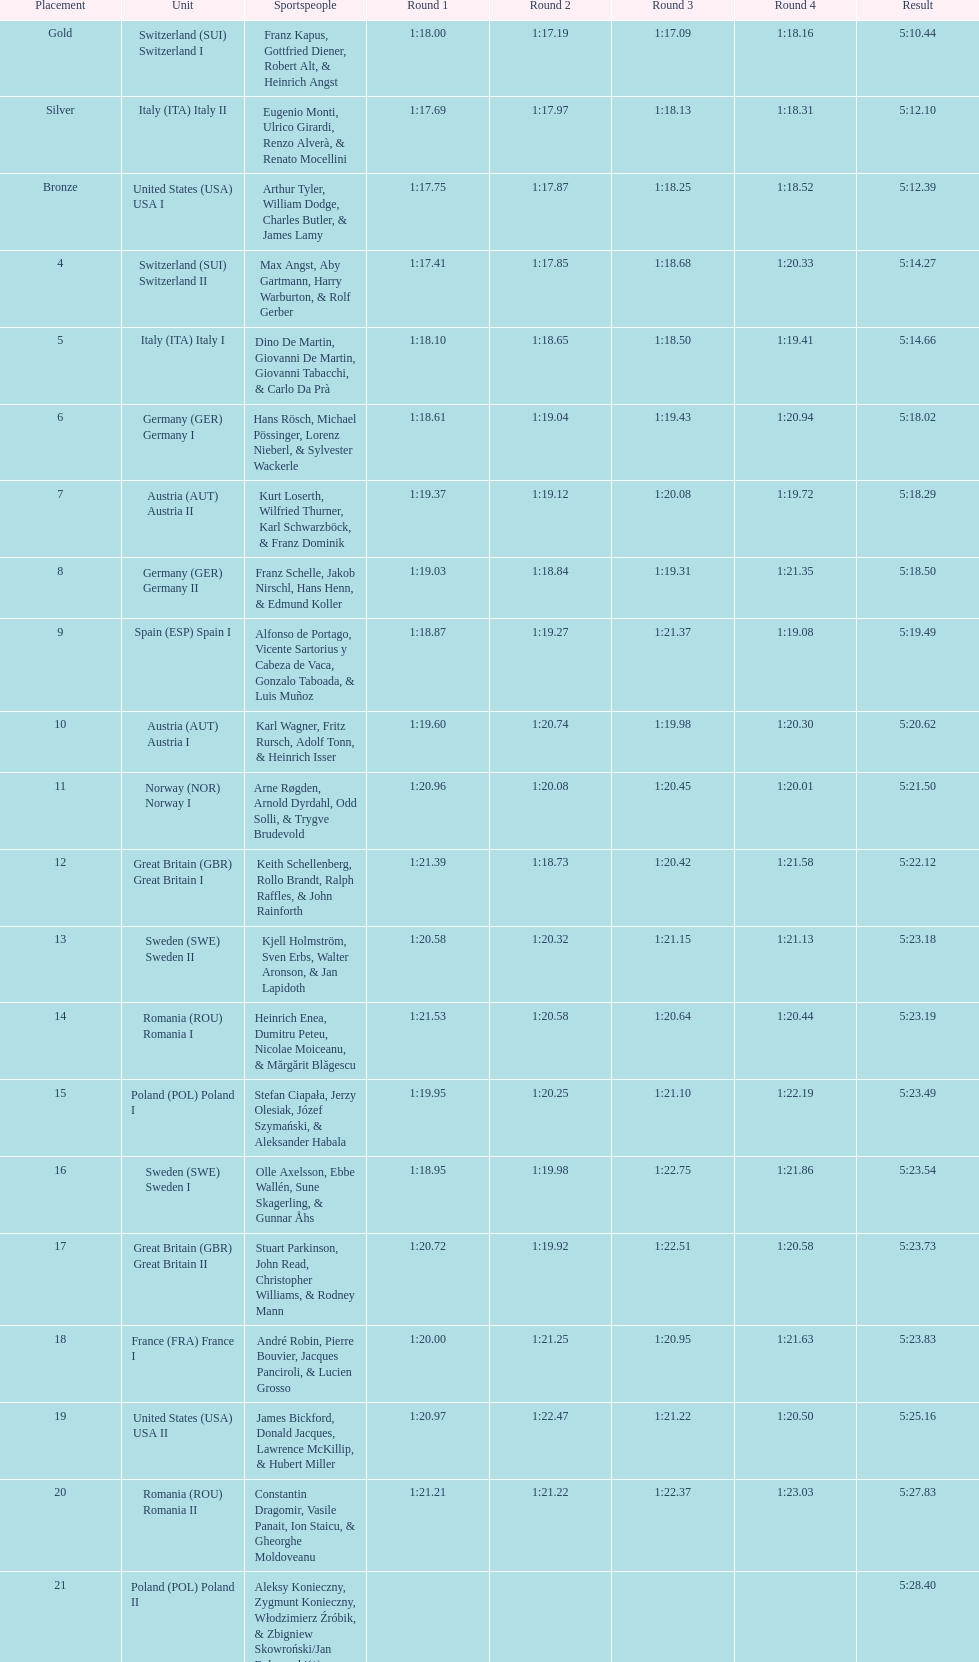Which team had the most time? Poland. 